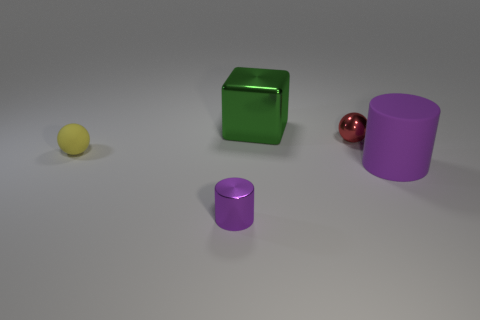Add 2 green metal things. How many objects exist? 7 Subtract all cylinders. How many objects are left? 3 Add 5 big metallic objects. How many big metallic objects are left? 6 Add 3 small red rubber things. How many small red rubber things exist? 3 Subtract 0 cyan spheres. How many objects are left? 5 Subtract all large objects. Subtract all tiny things. How many objects are left? 0 